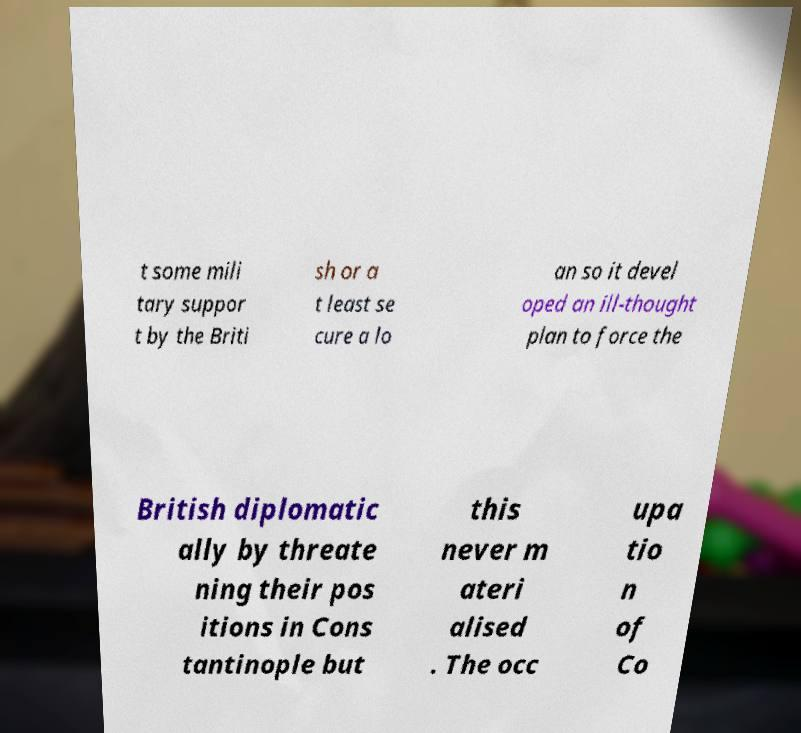There's text embedded in this image that I need extracted. Can you transcribe it verbatim? t some mili tary suppor t by the Briti sh or a t least se cure a lo an so it devel oped an ill-thought plan to force the British diplomatic ally by threate ning their pos itions in Cons tantinople but this never m ateri alised . The occ upa tio n of Co 